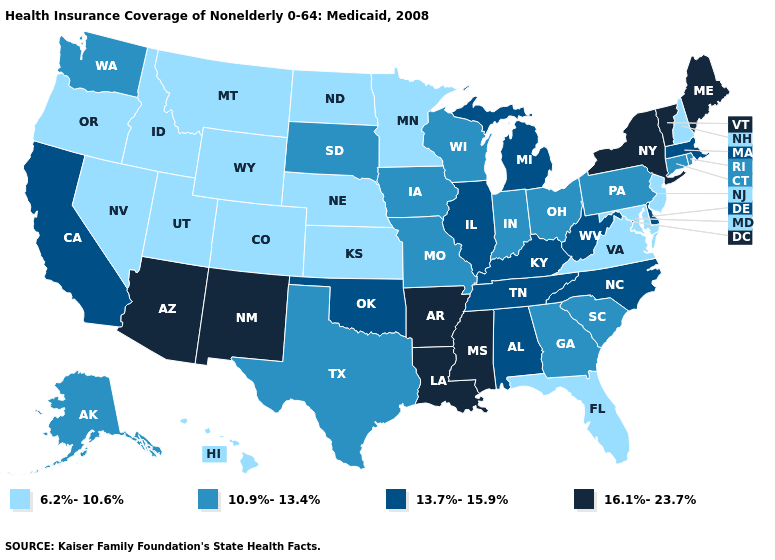Name the states that have a value in the range 16.1%-23.7%?
Concise answer only. Arizona, Arkansas, Louisiana, Maine, Mississippi, New Mexico, New York, Vermont. Does West Virginia have the lowest value in the USA?
Concise answer only. No. What is the highest value in the Northeast ?
Concise answer only. 16.1%-23.7%. Which states have the lowest value in the USA?
Short answer required. Colorado, Florida, Hawaii, Idaho, Kansas, Maryland, Minnesota, Montana, Nebraska, Nevada, New Hampshire, New Jersey, North Dakota, Oregon, Utah, Virginia, Wyoming. Which states hav the highest value in the Northeast?
Be succinct. Maine, New York, Vermont. Does Nevada have the highest value in the USA?
Short answer required. No. What is the value of Kentucky?
Keep it brief. 13.7%-15.9%. How many symbols are there in the legend?
Keep it brief. 4. Does Hawaii have the lowest value in the USA?
Quick response, please. Yes. Name the states that have a value in the range 13.7%-15.9%?
Quick response, please. Alabama, California, Delaware, Illinois, Kentucky, Massachusetts, Michigan, North Carolina, Oklahoma, Tennessee, West Virginia. Does North Carolina have the lowest value in the South?
Give a very brief answer. No. Name the states that have a value in the range 10.9%-13.4%?
Quick response, please. Alaska, Connecticut, Georgia, Indiana, Iowa, Missouri, Ohio, Pennsylvania, Rhode Island, South Carolina, South Dakota, Texas, Washington, Wisconsin. What is the value of Virginia?
Keep it brief. 6.2%-10.6%. Which states have the lowest value in the USA?
Write a very short answer. Colorado, Florida, Hawaii, Idaho, Kansas, Maryland, Minnesota, Montana, Nebraska, Nevada, New Hampshire, New Jersey, North Dakota, Oregon, Utah, Virginia, Wyoming. 